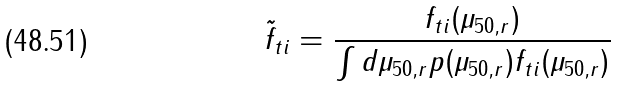Convert formula to latex. <formula><loc_0><loc_0><loc_500><loc_500>\tilde { f } _ { t i } = \frac { f _ { t i } ( \mu _ { 5 0 , r } ) } { \int d \mu _ { 5 0 , r } p ( \mu _ { 5 0 , r } ) f _ { t i } ( \mu _ { 5 0 , r } ) }</formula> 